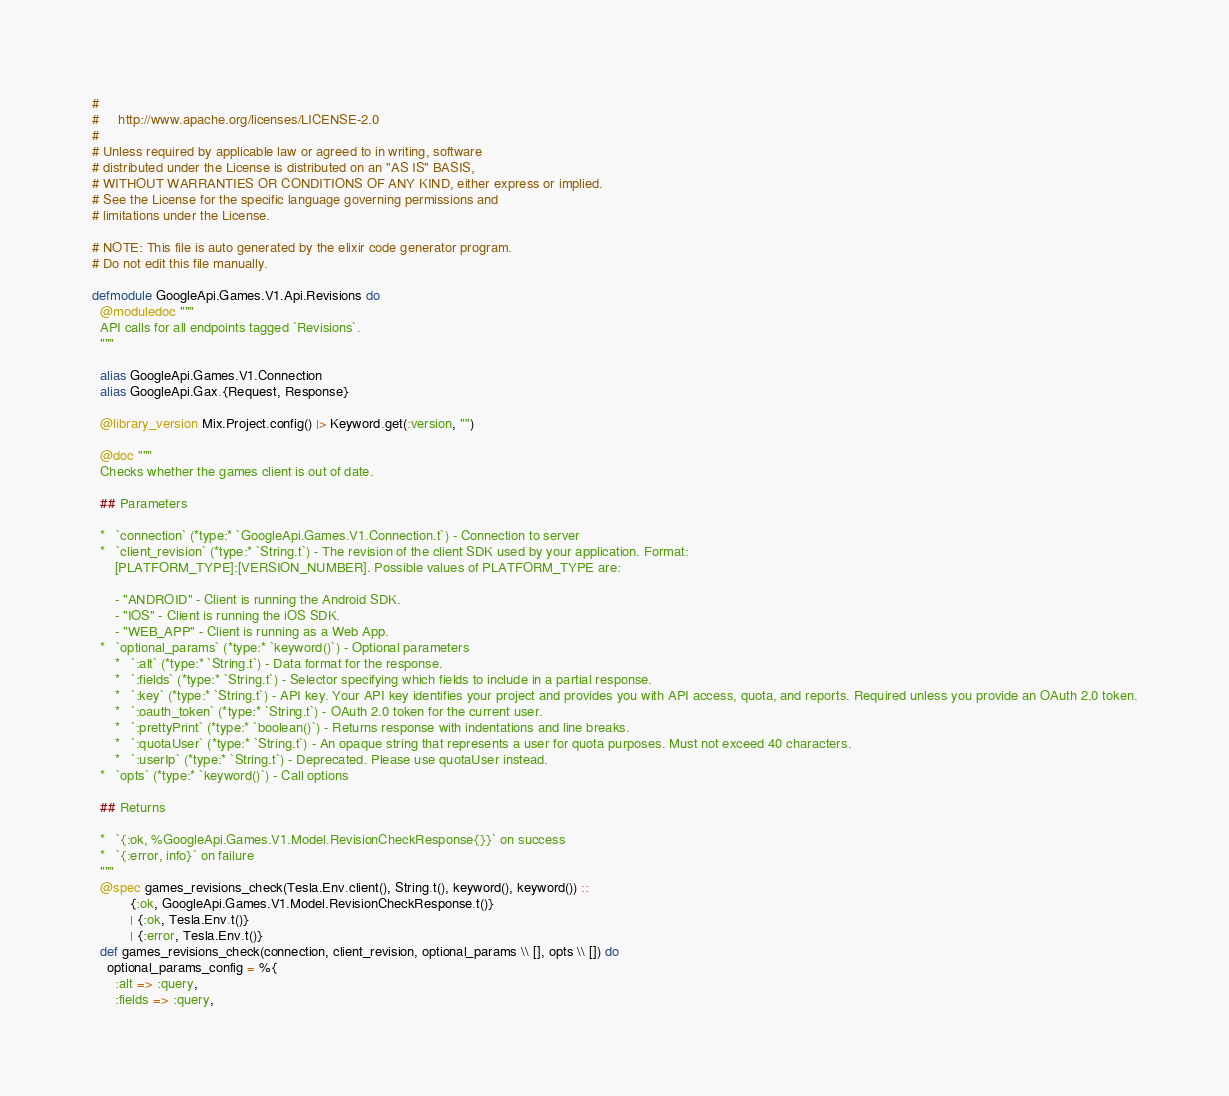<code> <loc_0><loc_0><loc_500><loc_500><_Elixir_>#
#     http://www.apache.org/licenses/LICENSE-2.0
#
# Unless required by applicable law or agreed to in writing, software
# distributed under the License is distributed on an "AS IS" BASIS,
# WITHOUT WARRANTIES OR CONDITIONS OF ANY KIND, either express or implied.
# See the License for the specific language governing permissions and
# limitations under the License.

# NOTE: This file is auto generated by the elixir code generator program.
# Do not edit this file manually.

defmodule GoogleApi.Games.V1.Api.Revisions do
  @moduledoc """
  API calls for all endpoints tagged `Revisions`.
  """

  alias GoogleApi.Games.V1.Connection
  alias GoogleApi.Gax.{Request, Response}

  @library_version Mix.Project.config() |> Keyword.get(:version, "")

  @doc """
  Checks whether the games client is out of date.

  ## Parameters

  *   `connection` (*type:* `GoogleApi.Games.V1.Connection.t`) - Connection to server
  *   `client_revision` (*type:* `String.t`) - The revision of the client SDK used by your application. Format:
      [PLATFORM_TYPE]:[VERSION_NUMBER]. Possible values of PLATFORM_TYPE are:
       
      - "ANDROID" - Client is running the Android SDK. 
      - "IOS" - Client is running the iOS SDK. 
      - "WEB_APP" - Client is running as a Web App.
  *   `optional_params` (*type:* `keyword()`) - Optional parameters
      *   `:alt` (*type:* `String.t`) - Data format for the response.
      *   `:fields` (*type:* `String.t`) - Selector specifying which fields to include in a partial response.
      *   `:key` (*type:* `String.t`) - API key. Your API key identifies your project and provides you with API access, quota, and reports. Required unless you provide an OAuth 2.0 token.
      *   `:oauth_token` (*type:* `String.t`) - OAuth 2.0 token for the current user.
      *   `:prettyPrint` (*type:* `boolean()`) - Returns response with indentations and line breaks.
      *   `:quotaUser` (*type:* `String.t`) - An opaque string that represents a user for quota purposes. Must not exceed 40 characters.
      *   `:userIp` (*type:* `String.t`) - Deprecated. Please use quotaUser instead.
  *   `opts` (*type:* `keyword()`) - Call options

  ## Returns

  *   `{:ok, %GoogleApi.Games.V1.Model.RevisionCheckResponse{}}` on success
  *   `{:error, info}` on failure
  """
  @spec games_revisions_check(Tesla.Env.client(), String.t(), keyword(), keyword()) ::
          {:ok, GoogleApi.Games.V1.Model.RevisionCheckResponse.t()}
          | {:ok, Tesla.Env.t()}
          | {:error, Tesla.Env.t()}
  def games_revisions_check(connection, client_revision, optional_params \\ [], opts \\ []) do
    optional_params_config = %{
      :alt => :query,
      :fields => :query,</code> 